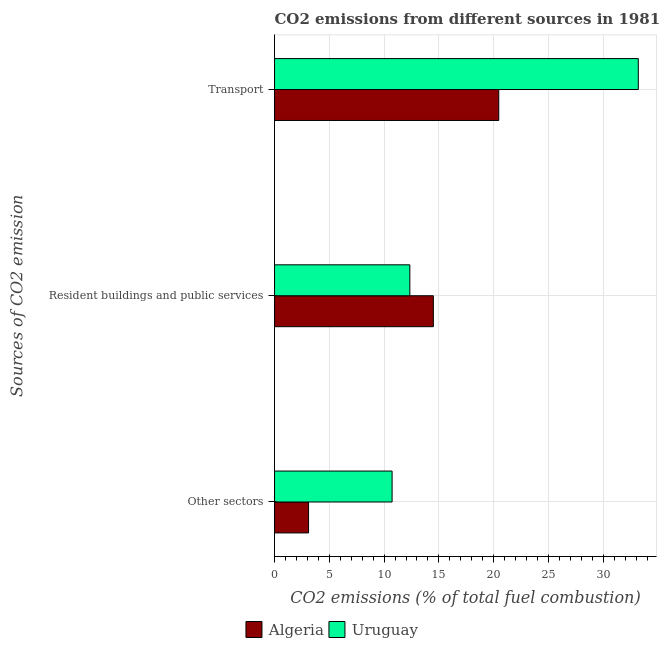Are the number of bars per tick equal to the number of legend labels?
Offer a terse response. Yes. What is the label of the 2nd group of bars from the top?
Give a very brief answer. Resident buildings and public services. What is the percentage of co2 emissions from resident buildings and public services in Algeria?
Your answer should be very brief. 14.49. Across all countries, what is the maximum percentage of co2 emissions from transport?
Provide a succinct answer. 33.2. Across all countries, what is the minimum percentage of co2 emissions from transport?
Your answer should be very brief. 20.46. In which country was the percentage of co2 emissions from transport maximum?
Provide a succinct answer. Uruguay. In which country was the percentage of co2 emissions from resident buildings and public services minimum?
Provide a short and direct response. Uruguay. What is the total percentage of co2 emissions from resident buildings and public services in the graph?
Keep it short and to the point. 26.84. What is the difference between the percentage of co2 emissions from other sectors in Uruguay and that in Algeria?
Offer a terse response. 7.62. What is the difference between the percentage of co2 emissions from other sectors in Uruguay and the percentage of co2 emissions from transport in Algeria?
Ensure brevity in your answer.  -9.73. What is the average percentage of co2 emissions from resident buildings and public services per country?
Your answer should be very brief. 13.42. What is the difference between the percentage of co2 emissions from resident buildings and public services and percentage of co2 emissions from transport in Algeria?
Your answer should be compact. -5.97. In how many countries, is the percentage of co2 emissions from resident buildings and public services greater than 28 %?
Your answer should be compact. 0. What is the ratio of the percentage of co2 emissions from resident buildings and public services in Uruguay to that in Algeria?
Offer a terse response. 0.85. Is the percentage of co2 emissions from other sectors in Uruguay less than that in Algeria?
Your response must be concise. No. Is the difference between the percentage of co2 emissions from transport in Uruguay and Algeria greater than the difference between the percentage of co2 emissions from other sectors in Uruguay and Algeria?
Your response must be concise. Yes. What is the difference between the highest and the second highest percentage of co2 emissions from other sectors?
Your response must be concise. 7.62. What is the difference between the highest and the lowest percentage of co2 emissions from other sectors?
Your answer should be compact. 7.62. Is the sum of the percentage of co2 emissions from other sectors in Uruguay and Algeria greater than the maximum percentage of co2 emissions from transport across all countries?
Offer a very short reply. No. What does the 2nd bar from the top in Resident buildings and public services represents?
Make the answer very short. Algeria. What does the 1st bar from the bottom in Resident buildings and public services represents?
Give a very brief answer. Algeria. Are all the bars in the graph horizontal?
Provide a succinct answer. Yes. How many countries are there in the graph?
Offer a terse response. 2. What is the difference between two consecutive major ticks on the X-axis?
Keep it short and to the point. 5. Where does the legend appear in the graph?
Your answer should be very brief. Bottom center. How many legend labels are there?
Give a very brief answer. 2. How are the legend labels stacked?
Your answer should be very brief. Horizontal. What is the title of the graph?
Provide a short and direct response. CO2 emissions from different sources in 1981. Does "Suriname" appear as one of the legend labels in the graph?
Ensure brevity in your answer.  No. What is the label or title of the X-axis?
Offer a terse response. CO2 emissions (% of total fuel combustion). What is the label or title of the Y-axis?
Your response must be concise. Sources of CO2 emission. What is the CO2 emissions (% of total fuel combustion) of Algeria in Other sectors?
Provide a succinct answer. 3.11. What is the CO2 emissions (% of total fuel combustion) of Uruguay in Other sectors?
Your answer should be compact. 10.73. What is the CO2 emissions (% of total fuel combustion) in Algeria in Resident buildings and public services?
Your response must be concise. 14.49. What is the CO2 emissions (% of total fuel combustion) of Uruguay in Resident buildings and public services?
Give a very brief answer. 12.35. What is the CO2 emissions (% of total fuel combustion) in Algeria in Transport?
Your answer should be compact. 20.46. What is the CO2 emissions (% of total fuel combustion) of Uruguay in Transport?
Provide a succinct answer. 33.2. Across all Sources of CO2 emission, what is the maximum CO2 emissions (% of total fuel combustion) in Algeria?
Offer a very short reply. 20.46. Across all Sources of CO2 emission, what is the maximum CO2 emissions (% of total fuel combustion) in Uruguay?
Make the answer very short. 33.2. Across all Sources of CO2 emission, what is the minimum CO2 emissions (% of total fuel combustion) of Algeria?
Offer a very short reply. 3.11. Across all Sources of CO2 emission, what is the minimum CO2 emissions (% of total fuel combustion) in Uruguay?
Offer a very short reply. 10.73. What is the total CO2 emissions (% of total fuel combustion) in Algeria in the graph?
Offer a terse response. 38.06. What is the total CO2 emissions (% of total fuel combustion) of Uruguay in the graph?
Provide a succinct answer. 56.28. What is the difference between the CO2 emissions (% of total fuel combustion) in Algeria in Other sectors and that in Resident buildings and public services?
Provide a short and direct response. -11.39. What is the difference between the CO2 emissions (% of total fuel combustion) in Uruguay in Other sectors and that in Resident buildings and public services?
Ensure brevity in your answer.  -1.62. What is the difference between the CO2 emissions (% of total fuel combustion) in Algeria in Other sectors and that in Transport?
Your answer should be very brief. -17.36. What is the difference between the CO2 emissions (% of total fuel combustion) in Uruguay in Other sectors and that in Transport?
Your response must be concise. -22.47. What is the difference between the CO2 emissions (% of total fuel combustion) in Algeria in Resident buildings and public services and that in Transport?
Make the answer very short. -5.97. What is the difference between the CO2 emissions (% of total fuel combustion) of Uruguay in Resident buildings and public services and that in Transport?
Offer a very short reply. -20.85. What is the difference between the CO2 emissions (% of total fuel combustion) of Algeria in Other sectors and the CO2 emissions (% of total fuel combustion) of Uruguay in Resident buildings and public services?
Ensure brevity in your answer.  -9.24. What is the difference between the CO2 emissions (% of total fuel combustion) of Algeria in Other sectors and the CO2 emissions (% of total fuel combustion) of Uruguay in Transport?
Your answer should be compact. -30.09. What is the difference between the CO2 emissions (% of total fuel combustion) in Algeria in Resident buildings and public services and the CO2 emissions (% of total fuel combustion) in Uruguay in Transport?
Provide a short and direct response. -18.7. What is the average CO2 emissions (% of total fuel combustion) of Algeria per Sources of CO2 emission?
Provide a short and direct response. 12.69. What is the average CO2 emissions (% of total fuel combustion) in Uruguay per Sources of CO2 emission?
Offer a terse response. 18.76. What is the difference between the CO2 emissions (% of total fuel combustion) in Algeria and CO2 emissions (% of total fuel combustion) in Uruguay in Other sectors?
Keep it short and to the point. -7.62. What is the difference between the CO2 emissions (% of total fuel combustion) of Algeria and CO2 emissions (% of total fuel combustion) of Uruguay in Resident buildings and public services?
Provide a short and direct response. 2.15. What is the difference between the CO2 emissions (% of total fuel combustion) in Algeria and CO2 emissions (% of total fuel combustion) in Uruguay in Transport?
Offer a terse response. -12.74. What is the ratio of the CO2 emissions (% of total fuel combustion) of Algeria in Other sectors to that in Resident buildings and public services?
Make the answer very short. 0.21. What is the ratio of the CO2 emissions (% of total fuel combustion) of Uruguay in Other sectors to that in Resident buildings and public services?
Offer a terse response. 0.87. What is the ratio of the CO2 emissions (% of total fuel combustion) of Algeria in Other sectors to that in Transport?
Provide a short and direct response. 0.15. What is the ratio of the CO2 emissions (% of total fuel combustion) of Uruguay in Other sectors to that in Transport?
Make the answer very short. 0.32. What is the ratio of the CO2 emissions (% of total fuel combustion) in Algeria in Resident buildings and public services to that in Transport?
Your answer should be compact. 0.71. What is the ratio of the CO2 emissions (% of total fuel combustion) in Uruguay in Resident buildings and public services to that in Transport?
Give a very brief answer. 0.37. What is the difference between the highest and the second highest CO2 emissions (% of total fuel combustion) in Algeria?
Keep it short and to the point. 5.97. What is the difference between the highest and the second highest CO2 emissions (% of total fuel combustion) of Uruguay?
Offer a very short reply. 20.85. What is the difference between the highest and the lowest CO2 emissions (% of total fuel combustion) of Algeria?
Keep it short and to the point. 17.36. What is the difference between the highest and the lowest CO2 emissions (% of total fuel combustion) in Uruguay?
Give a very brief answer. 22.47. 